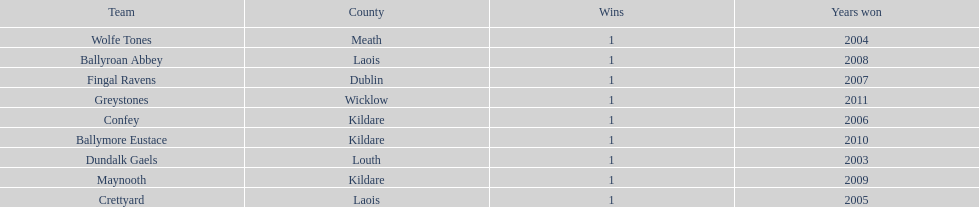What is the number of wins for confey 1. Would you be able to parse every entry in this table? {'header': ['Team', 'County', 'Wins', 'Years won'], 'rows': [['Wolfe Tones', 'Meath', '1', '2004'], ['Ballyroan Abbey', 'Laois', '1', '2008'], ['Fingal Ravens', 'Dublin', '1', '2007'], ['Greystones', 'Wicklow', '1', '2011'], ['Confey', 'Kildare', '1', '2006'], ['Ballymore Eustace', 'Kildare', '1', '2010'], ['Dundalk Gaels', 'Louth', '1', '2003'], ['Maynooth', 'Kildare', '1', '2009'], ['Crettyard', 'Laois', '1', '2005']]} 